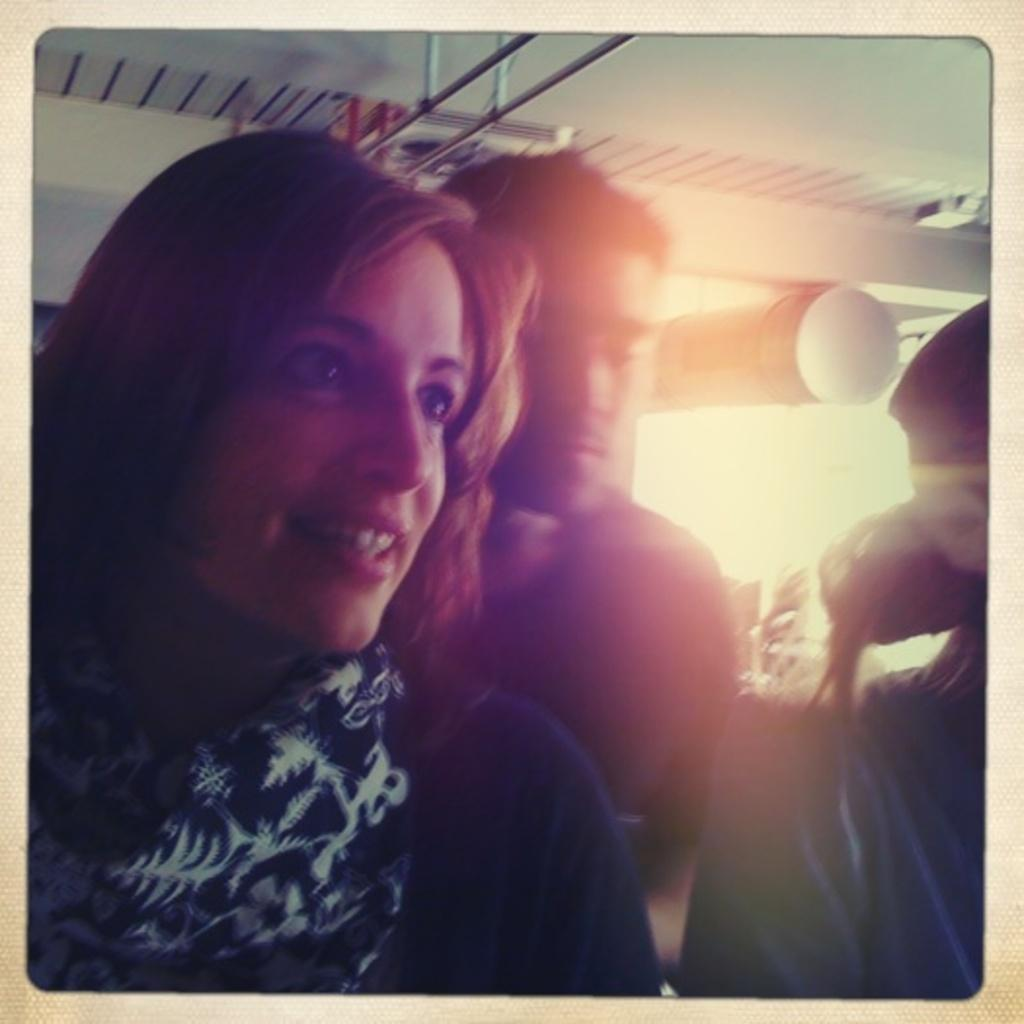What are the two people in the image? There is a man and a woman in the image. Can you describe the relationship between the man and the woman in the image? The facts provided do not give any information about the relationship between the man and the woman. What type of zinc object is being used by the man in the image? There is no zinc object present in the image. What appliance is the woman using in the image? The facts provided do not give any information about an appliance being used by the woman. 